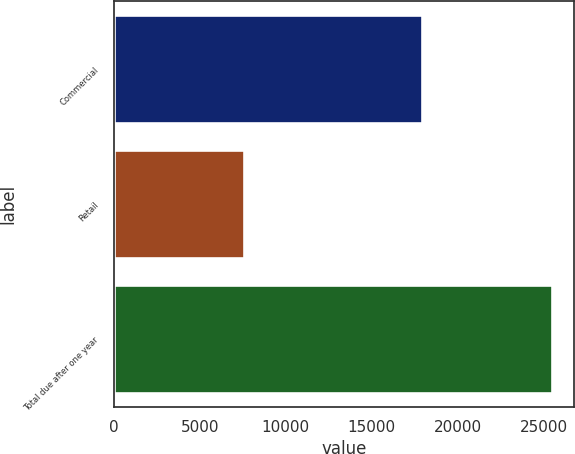Convert chart to OTSL. <chart><loc_0><loc_0><loc_500><loc_500><bar_chart><fcel>Commercial<fcel>Retail<fcel>Total due after one year<nl><fcel>17930.8<fcel>7570.4<fcel>25501.2<nl></chart> 